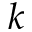Convert formula to latex. <formula><loc_0><loc_0><loc_500><loc_500>k</formula> 